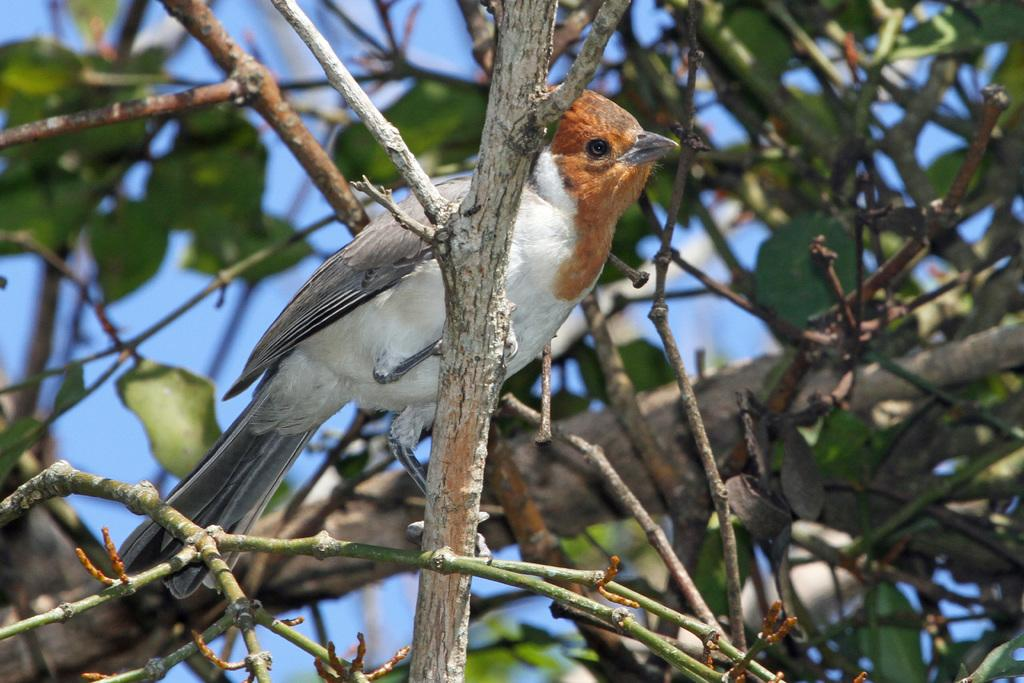What type of plant can be seen in the image? There is a tree in the image. What type of animal can be seen in the image? There is a bird in the image. Where is the bird located in relation to the tree? The bird is sitting on a branch of the tree. What type of wire is visible in the image? There is no wire present in the image. What type of rhythm is the bird following while sitting on the branch? The image does not provide information about the bird's rhythm, as it only shows the bird sitting on a branch. 